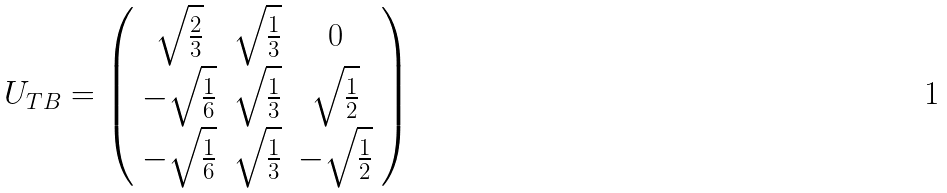<formula> <loc_0><loc_0><loc_500><loc_500>U _ { T B } = \left ( \begin{array} { c c c } \sqrt { \frac { 2 } { 3 } } & \sqrt { \frac { 1 } { 3 } } & 0 \\ - \sqrt { \frac { 1 } { 6 } } & \sqrt { \frac { 1 } { 3 } } & \sqrt { \frac { 1 } { 2 } } \\ - \sqrt { \frac { 1 } { 6 } } & \sqrt { \frac { 1 } { 3 } } & - \sqrt { \frac { 1 } { 2 } } \end{array} \right )</formula> 